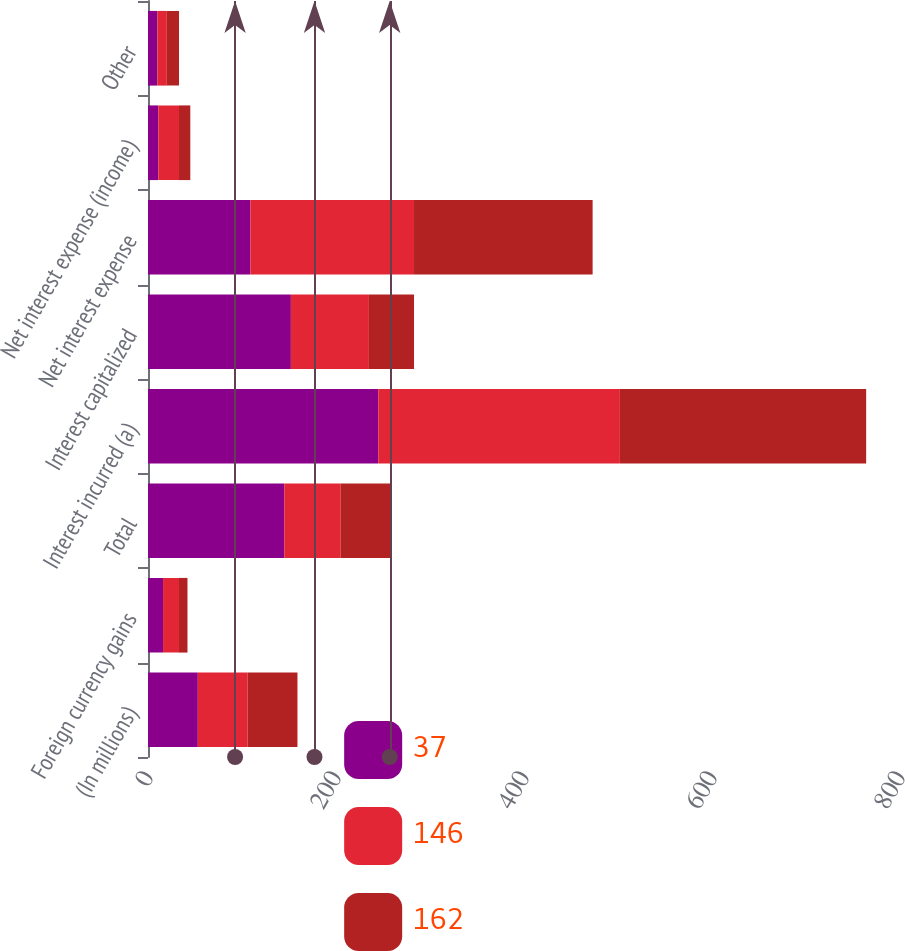Convert chart. <chart><loc_0><loc_0><loc_500><loc_500><stacked_bar_chart><ecel><fcel>(In millions)<fcel>Foreign currency gains<fcel>Total<fcel>Interest incurred (a)<fcel>Interest capitalized<fcel>Net interest expense<fcel>Net interest expense (income)<fcel>Other<nl><fcel>37<fcel>53<fcel>16<fcel>145<fcel>245<fcel>152<fcel>109<fcel>11<fcel>10<nl><fcel>146<fcel>53<fcel>17<fcel>60<fcel>257<fcel>83<fcel>174<fcel>22<fcel>10<nl><fcel>162<fcel>53<fcel>9<fcel>53<fcel>262<fcel>48<fcel>190<fcel>12<fcel>13<nl></chart> 